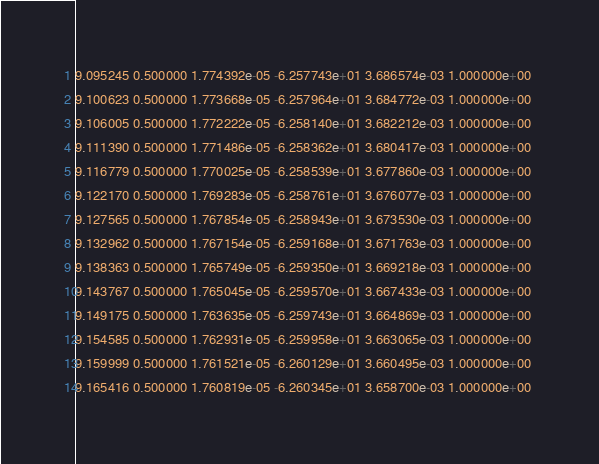Convert code to text. <code><loc_0><loc_0><loc_500><loc_500><_SQL_>9.095245 0.500000 1.774392e-05 -6.257743e+01 3.686574e-03 1.000000e+00 
9.100623 0.500000 1.773668e-05 -6.257964e+01 3.684772e-03 1.000000e+00 
9.106005 0.500000 1.772222e-05 -6.258140e+01 3.682212e-03 1.000000e+00 
9.111390 0.500000 1.771486e-05 -6.258362e+01 3.680417e-03 1.000000e+00 
9.116779 0.500000 1.770025e-05 -6.258539e+01 3.677860e-03 1.000000e+00 
9.122170 0.500000 1.769283e-05 -6.258761e+01 3.676077e-03 1.000000e+00 
9.127565 0.500000 1.767854e-05 -6.258943e+01 3.673530e-03 1.000000e+00 
9.132962 0.500000 1.767154e-05 -6.259168e+01 3.671763e-03 1.000000e+00 
9.138363 0.500000 1.765749e-05 -6.259350e+01 3.669218e-03 1.000000e+00 
9.143767 0.500000 1.765045e-05 -6.259570e+01 3.667433e-03 1.000000e+00 
9.149175 0.500000 1.763635e-05 -6.259743e+01 3.664869e-03 1.000000e+00 
9.154585 0.500000 1.762931e-05 -6.259958e+01 3.663065e-03 1.000000e+00 
9.159999 0.500000 1.761521e-05 -6.260129e+01 3.660495e-03 1.000000e+00 
9.165416 0.500000 1.760819e-05 -6.260345e+01 3.658700e-03 1.000000e+00 </code> 